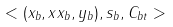<formula> <loc_0><loc_0><loc_500><loc_500>< ( x _ { b } , x x _ { b } , y _ { b } ) , s _ { b } , C _ { b t } ></formula> 